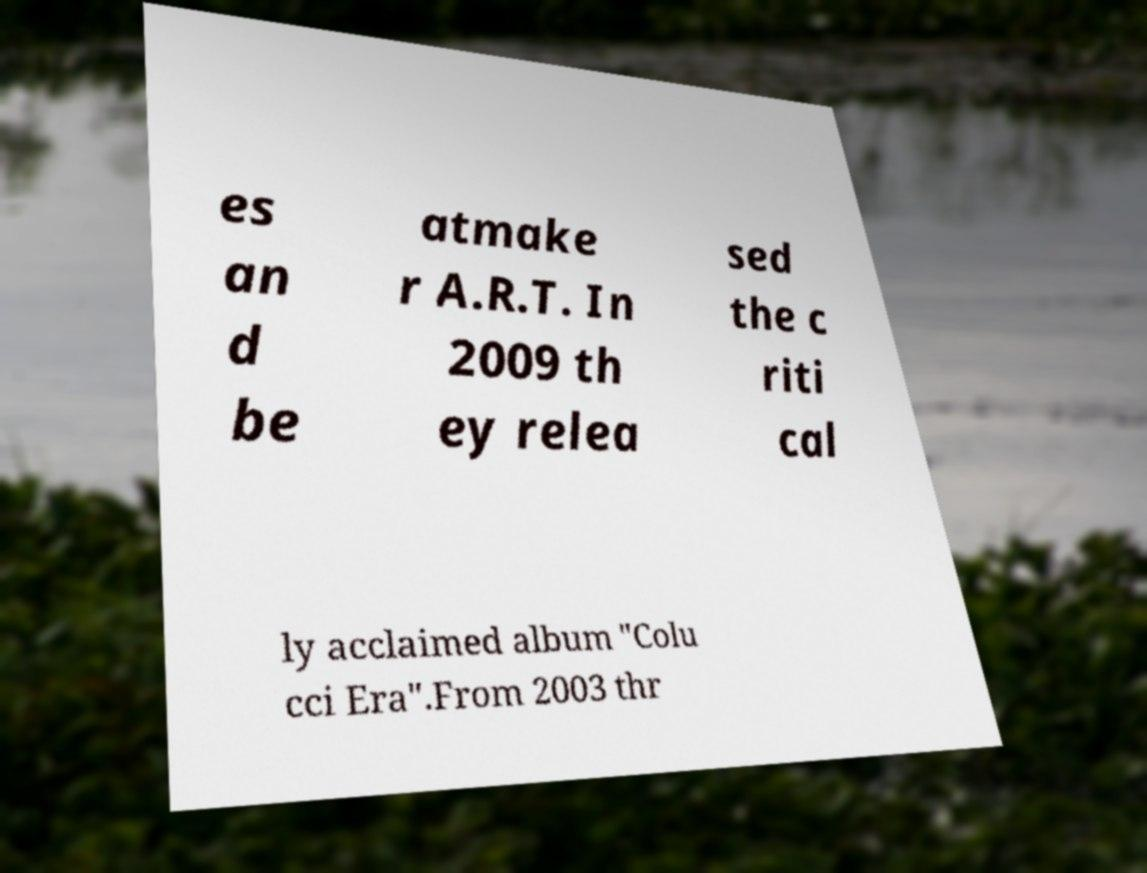There's text embedded in this image that I need extracted. Can you transcribe it verbatim? es an d be atmake r A.R.T. In 2009 th ey relea sed the c riti cal ly acclaimed album "Colu cci Era".From 2003 thr 